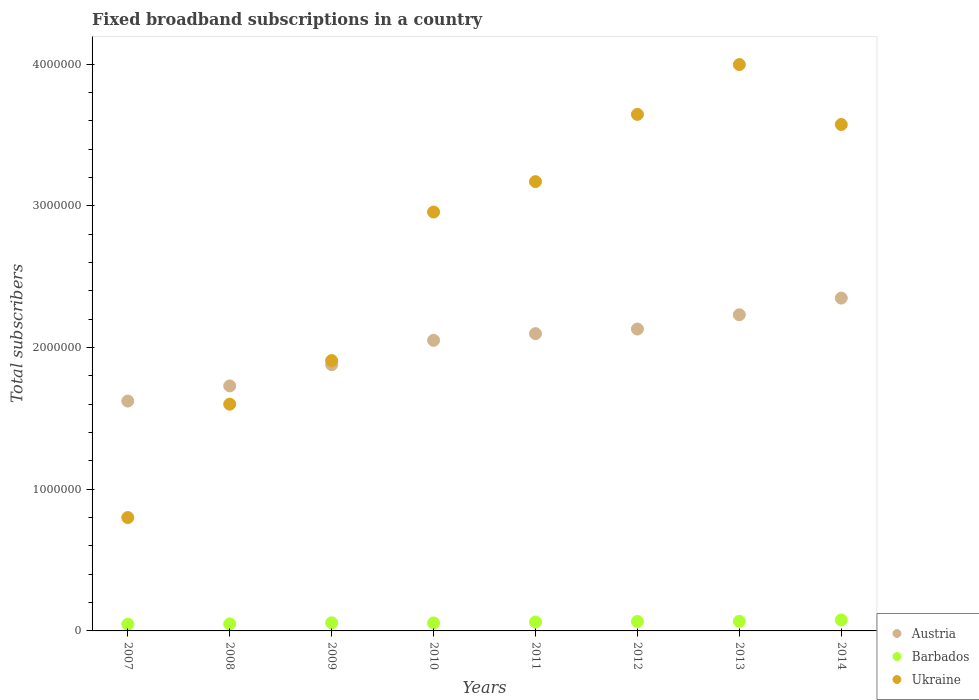How many different coloured dotlines are there?
Ensure brevity in your answer.  3. What is the number of broadband subscriptions in Barbados in 2007?
Provide a short and direct response. 4.71e+04. Across all years, what is the maximum number of broadband subscriptions in Austria?
Offer a very short reply. 2.35e+06. Across all years, what is the minimum number of broadband subscriptions in Barbados?
Offer a very short reply. 4.71e+04. In which year was the number of broadband subscriptions in Austria minimum?
Ensure brevity in your answer.  2007. What is the total number of broadband subscriptions in Barbados in the graph?
Offer a terse response. 4.84e+05. What is the difference between the number of broadband subscriptions in Ukraine in 2007 and that in 2008?
Your response must be concise. -8.00e+05. What is the difference between the number of broadband subscriptions in Barbados in 2013 and the number of broadband subscriptions in Austria in 2007?
Offer a very short reply. -1.55e+06. What is the average number of broadband subscriptions in Austria per year?
Give a very brief answer. 2.01e+06. In the year 2008, what is the difference between the number of broadband subscriptions in Ukraine and number of broadband subscriptions in Austria?
Your response must be concise. -1.29e+05. What is the ratio of the number of broadband subscriptions in Austria in 2007 to that in 2014?
Ensure brevity in your answer.  0.69. Is the number of broadband subscriptions in Ukraine in 2007 less than that in 2012?
Ensure brevity in your answer.  Yes. Is the difference between the number of broadband subscriptions in Ukraine in 2011 and 2012 greater than the difference between the number of broadband subscriptions in Austria in 2011 and 2012?
Ensure brevity in your answer.  No. What is the difference between the highest and the second highest number of broadband subscriptions in Barbados?
Ensure brevity in your answer.  9360. What is the difference between the highest and the lowest number of broadband subscriptions in Austria?
Keep it short and to the point. 7.27e+05. In how many years, is the number of broadband subscriptions in Barbados greater than the average number of broadband subscriptions in Barbados taken over all years?
Provide a succinct answer. 4. How many dotlines are there?
Your response must be concise. 3. Are the values on the major ticks of Y-axis written in scientific E-notation?
Your answer should be very brief. No. Does the graph contain grids?
Offer a very short reply. No. How many legend labels are there?
Provide a succinct answer. 3. What is the title of the graph?
Make the answer very short. Fixed broadband subscriptions in a country. What is the label or title of the X-axis?
Offer a very short reply. Years. What is the label or title of the Y-axis?
Provide a short and direct response. Total subscribers. What is the Total subscribers in Austria in 2007?
Make the answer very short. 1.62e+06. What is the Total subscribers in Barbados in 2007?
Ensure brevity in your answer.  4.71e+04. What is the Total subscribers in Ukraine in 2007?
Keep it short and to the point. 8.00e+05. What is the Total subscribers of Austria in 2008?
Make the answer very short. 1.73e+06. What is the Total subscribers in Barbados in 2008?
Your answer should be compact. 4.92e+04. What is the Total subscribers of Ukraine in 2008?
Offer a terse response. 1.60e+06. What is the Total subscribers in Austria in 2009?
Give a very brief answer. 1.88e+06. What is the Total subscribers in Barbados in 2009?
Your answer should be compact. 5.73e+04. What is the Total subscribers of Ukraine in 2009?
Give a very brief answer. 1.91e+06. What is the Total subscribers of Austria in 2010?
Ensure brevity in your answer.  2.05e+06. What is the Total subscribers of Barbados in 2010?
Make the answer very short. 5.62e+04. What is the Total subscribers in Ukraine in 2010?
Keep it short and to the point. 2.96e+06. What is the Total subscribers in Austria in 2011?
Offer a terse response. 2.10e+06. What is the Total subscribers in Barbados in 2011?
Give a very brief answer. 6.26e+04. What is the Total subscribers in Ukraine in 2011?
Your answer should be compact. 3.17e+06. What is the Total subscribers in Austria in 2012?
Make the answer very short. 2.13e+06. What is the Total subscribers of Barbados in 2012?
Offer a terse response. 6.69e+04. What is the Total subscribers in Ukraine in 2012?
Provide a short and direct response. 3.64e+06. What is the Total subscribers in Austria in 2013?
Offer a terse response. 2.23e+06. What is the Total subscribers in Barbados in 2013?
Your answer should be compact. 6.78e+04. What is the Total subscribers in Ukraine in 2013?
Your answer should be very brief. 4.00e+06. What is the Total subscribers in Austria in 2014?
Ensure brevity in your answer.  2.35e+06. What is the Total subscribers of Barbados in 2014?
Offer a terse response. 7.72e+04. What is the Total subscribers of Ukraine in 2014?
Make the answer very short. 3.57e+06. Across all years, what is the maximum Total subscribers in Austria?
Your answer should be very brief. 2.35e+06. Across all years, what is the maximum Total subscribers of Barbados?
Offer a terse response. 7.72e+04. Across all years, what is the maximum Total subscribers in Ukraine?
Your answer should be very brief. 4.00e+06. Across all years, what is the minimum Total subscribers of Austria?
Offer a very short reply. 1.62e+06. Across all years, what is the minimum Total subscribers of Barbados?
Offer a very short reply. 4.71e+04. Across all years, what is the minimum Total subscribers in Ukraine?
Provide a succinct answer. 8.00e+05. What is the total Total subscribers in Austria in the graph?
Ensure brevity in your answer.  1.61e+07. What is the total Total subscribers of Barbados in the graph?
Offer a very short reply. 4.84e+05. What is the total Total subscribers of Ukraine in the graph?
Your response must be concise. 2.16e+07. What is the difference between the Total subscribers in Austria in 2007 and that in 2008?
Your answer should be very brief. -1.07e+05. What is the difference between the Total subscribers of Barbados in 2007 and that in 2008?
Provide a succinct answer. -2083. What is the difference between the Total subscribers in Ukraine in 2007 and that in 2008?
Your response must be concise. -8.00e+05. What is the difference between the Total subscribers of Austria in 2007 and that in 2009?
Provide a short and direct response. -2.57e+05. What is the difference between the Total subscribers of Barbados in 2007 and that in 2009?
Your response must be concise. -1.02e+04. What is the difference between the Total subscribers of Ukraine in 2007 and that in 2009?
Offer a terse response. -1.11e+06. What is the difference between the Total subscribers of Austria in 2007 and that in 2010?
Your response must be concise. -4.28e+05. What is the difference between the Total subscribers of Barbados in 2007 and that in 2010?
Your answer should be very brief. -9057. What is the difference between the Total subscribers in Ukraine in 2007 and that in 2010?
Make the answer very short. -2.16e+06. What is the difference between the Total subscribers of Austria in 2007 and that in 2011?
Your answer should be very brief. -4.76e+05. What is the difference between the Total subscribers of Barbados in 2007 and that in 2011?
Provide a succinct answer. -1.55e+04. What is the difference between the Total subscribers of Ukraine in 2007 and that in 2011?
Provide a short and direct response. -2.37e+06. What is the difference between the Total subscribers in Austria in 2007 and that in 2012?
Ensure brevity in your answer.  -5.08e+05. What is the difference between the Total subscribers in Barbados in 2007 and that in 2012?
Your response must be concise. -1.98e+04. What is the difference between the Total subscribers in Ukraine in 2007 and that in 2012?
Offer a terse response. -2.84e+06. What is the difference between the Total subscribers in Austria in 2007 and that in 2013?
Offer a terse response. -6.09e+05. What is the difference between the Total subscribers in Barbados in 2007 and that in 2013?
Ensure brevity in your answer.  -2.07e+04. What is the difference between the Total subscribers in Ukraine in 2007 and that in 2013?
Your answer should be very brief. -3.20e+06. What is the difference between the Total subscribers of Austria in 2007 and that in 2014?
Your answer should be very brief. -7.27e+05. What is the difference between the Total subscribers in Barbados in 2007 and that in 2014?
Your response must be concise. -3.00e+04. What is the difference between the Total subscribers of Ukraine in 2007 and that in 2014?
Make the answer very short. -2.77e+06. What is the difference between the Total subscribers in Austria in 2008 and that in 2009?
Your answer should be compact. -1.50e+05. What is the difference between the Total subscribers in Barbados in 2008 and that in 2009?
Keep it short and to the point. -8089. What is the difference between the Total subscribers of Ukraine in 2008 and that in 2009?
Give a very brief answer. -3.08e+05. What is the difference between the Total subscribers of Austria in 2008 and that in 2010?
Make the answer very short. -3.21e+05. What is the difference between the Total subscribers of Barbados in 2008 and that in 2010?
Give a very brief answer. -6974. What is the difference between the Total subscribers in Ukraine in 2008 and that in 2010?
Give a very brief answer. -1.36e+06. What is the difference between the Total subscribers in Austria in 2008 and that in 2011?
Your answer should be compact. -3.69e+05. What is the difference between the Total subscribers in Barbados in 2008 and that in 2011?
Offer a terse response. -1.34e+04. What is the difference between the Total subscribers in Ukraine in 2008 and that in 2011?
Offer a terse response. -1.57e+06. What is the difference between the Total subscribers in Austria in 2008 and that in 2012?
Your answer should be very brief. -4.01e+05. What is the difference between the Total subscribers of Barbados in 2008 and that in 2012?
Provide a succinct answer. -1.77e+04. What is the difference between the Total subscribers of Ukraine in 2008 and that in 2012?
Make the answer very short. -2.04e+06. What is the difference between the Total subscribers of Austria in 2008 and that in 2013?
Ensure brevity in your answer.  -5.02e+05. What is the difference between the Total subscribers of Barbados in 2008 and that in 2013?
Your answer should be compact. -1.86e+04. What is the difference between the Total subscribers of Ukraine in 2008 and that in 2013?
Give a very brief answer. -2.40e+06. What is the difference between the Total subscribers in Austria in 2008 and that in 2014?
Keep it short and to the point. -6.20e+05. What is the difference between the Total subscribers of Barbados in 2008 and that in 2014?
Your response must be concise. -2.79e+04. What is the difference between the Total subscribers of Ukraine in 2008 and that in 2014?
Your answer should be very brief. -1.97e+06. What is the difference between the Total subscribers in Austria in 2009 and that in 2010?
Give a very brief answer. -1.72e+05. What is the difference between the Total subscribers in Barbados in 2009 and that in 2010?
Offer a terse response. 1115. What is the difference between the Total subscribers of Ukraine in 2009 and that in 2010?
Offer a very short reply. -1.05e+06. What is the difference between the Total subscribers of Austria in 2009 and that in 2011?
Make the answer very short. -2.19e+05. What is the difference between the Total subscribers in Barbados in 2009 and that in 2011?
Ensure brevity in your answer.  -5329. What is the difference between the Total subscribers in Ukraine in 2009 and that in 2011?
Your answer should be very brief. -1.26e+06. What is the difference between the Total subscribers in Austria in 2009 and that in 2012?
Provide a succinct answer. -2.52e+05. What is the difference between the Total subscribers of Barbados in 2009 and that in 2012?
Keep it short and to the point. -9579. What is the difference between the Total subscribers in Ukraine in 2009 and that in 2012?
Give a very brief answer. -1.74e+06. What is the difference between the Total subscribers of Austria in 2009 and that in 2013?
Offer a terse response. -3.52e+05. What is the difference between the Total subscribers in Barbados in 2009 and that in 2013?
Your response must be concise. -1.05e+04. What is the difference between the Total subscribers of Ukraine in 2009 and that in 2013?
Offer a very short reply. -2.09e+06. What is the difference between the Total subscribers in Austria in 2009 and that in 2014?
Provide a short and direct response. -4.70e+05. What is the difference between the Total subscribers of Barbados in 2009 and that in 2014?
Your answer should be very brief. -1.99e+04. What is the difference between the Total subscribers of Ukraine in 2009 and that in 2014?
Your answer should be compact. -1.67e+06. What is the difference between the Total subscribers in Austria in 2010 and that in 2011?
Your answer should be very brief. -4.73e+04. What is the difference between the Total subscribers in Barbados in 2010 and that in 2011?
Offer a terse response. -6444. What is the difference between the Total subscribers in Ukraine in 2010 and that in 2011?
Your answer should be compact. -2.15e+05. What is the difference between the Total subscribers of Austria in 2010 and that in 2012?
Offer a terse response. -7.98e+04. What is the difference between the Total subscribers of Barbados in 2010 and that in 2012?
Provide a succinct answer. -1.07e+04. What is the difference between the Total subscribers in Ukraine in 2010 and that in 2012?
Ensure brevity in your answer.  -6.89e+05. What is the difference between the Total subscribers in Austria in 2010 and that in 2013?
Offer a very short reply. -1.81e+05. What is the difference between the Total subscribers of Barbados in 2010 and that in 2013?
Provide a succinct answer. -1.16e+04. What is the difference between the Total subscribers in Ukraine in 2010 and that in 2013?
Keep it short and to the point. -1.04e+06. What is the difference between the Total subscribers in Austria in 2010 and that in 2014?
Your answer should be compact. -2.98e+05. What is the difference between the Total subscribers in Barbados in 2010 and that in 2014?
Ensure brevity in your answer.  -2.10e+04. What is the difference between the Total subscribers of Ukraine in 2010 and that in 2014?
Give a very brief answer. -6.18e+05. What is the difference between the Total subscribers in Austria in 2011 and that in 2012?
Provide a short and direct response. -3.25e+04. What is the difference between the Total subscribers of Barbados in 2011 and that in 2012?
Ensure brevity in your answer.  -4250. What is the difference between the Total subscribers of Ukraine in 2011 and that in 2012?
Your answer should be very brief. -4.75e+05. What is the difference between the Total subscribers of Austria in 2011 and that in 2013?
Your answer should be very brief. -1.33e+05. What is the difference between the Total subscribers of Barbados in 2011 and that in 2013?
Give a very brief answer. -5164. What is the difference between the Total subscribers of Ukraine in 2011 and that in 2013?
Offer a terse response. -8.26e+05. What is the difference between the Total subscribers of Austria in 2011 and that in 2014?
Keep it short and to the point. -2.51e+05. What is the difference between the Total subscribers in Barbados in 2011 and that in 2014?
Make the answer very short. -1.45e+04. What is the difference between the Total subscribers of Ukraine in 2011 and that in 2014?
Ensure brevity in your answer.  -4.03e+05. What is the difference between the Total subscribers of Austria in 2012 and that in 2013?
Offer a terse response. -1.01e+05. What is the difference between the Total subscribers in Barbados in 2012 and that in 2013?
Ensure brevity in your answer.  -914. What is the difference between the Total subscribers in Ukraine in 2012 and that in 2013?
Ensure brevity in your answer.  -3.52e+05. What is the difference between the Total subscribers of Austria in 2012 and that in 2014?
Your response must be concise. -2.18e+05. What is the difference between the Total subscribers of Barbados in 2012 and that in 2014?
Your answer should be very brief. -1.03e+04. What is the difference between the Total subscribers in Ukraine in 2012 and that in 2014?
Ensure brevity in your answer.  7.15e+04. What is the difference between the Total subscribers of Austria in 2013 and that in 2014?
Make the answer very short. -1.18e+05. What is the difference between the Total subscribers of Barbados in 2013 and that in 2014?
Provide a short and direct response. -9360. What is the difference between the Total subscribers of Ukraine in 2013 and that in 2014?
Your answer should be very brief. 4.23e+05. What is the difference between the Total subscribers of Austria in 2007 and the Total subscribers of Barbados in 2008?
Make the answer very short. 1.57e+06. What is the difference between the Total subscribers of Austria in 2007 and the Total subscribers of Ukraine in 2008?
Provide a short and direct response. 2.20e+04. What is the difference between the Total subscribers of Barbados in 2007 and the Total subscribers of Ukraine in 2008?
Ensure brevity in your answer.  -1.55e+06. What is the difference between the Total subscribers of Austria in 2007 and the Total subscribers of Barbados in 2009?
Your answer should be very brief. 1.56e+06. What is the difference between the Total subscribers of Austria in 2007 and the Total subscribers of Ukraine in 2009?
Make the answer very short. -2.86e+05. What is the difference between the Total subscribers of Barbados in 2007 and the Total subscribers of Ukraine in 2009?
Keep it short and to the point. -1.86e+06. What is the difference between the Total subscribers of Austria in 2007 and the Total subscribers of Barbados in 2010?
Your answer should be compact. 1.57e+06. What is the difference between the Total subscribers in Austria in 2007 and the Total subscribers in Ukraine in 2010?
Provide a short and direct response. -1.33e+06. What is the difference between the Total subscribers in Barbados in 2007 and the Total subscribers in Ukraine in 2010?
Your response must be concise. -2.91e+06. What is the difference between the Total subscribers of Austria in 2007 and the Total subscribers of Barbados in 2011?
Your response must be concise. 1.56e+06. What is the difference between the Total subscribers in Austria in 2007 and the Total subscribers in Ukraine in 2011?
Offer a terse response. -1.55e+06. What is the difference between the Total subscribers of Barbados in 2007 and the Total subscribers of Ukraine in 2011?
Your answer should be compact. -3.12e+06. What is the difference between the Total subscribers of Austria in 2007 and the Total subscribers of Barbados in 2012?
Give a very brief answer. 1.56e+06. What is the difference between the Total subscribers of Austria in 2007 and the Total subscribers of Ukraine in 2012?
Your answer should be compact. -2.02e+06. What is the difference between the Total subscribers of Barbados in 2007 and the Total subscribers of Ukraine in 2012?
Make the answer very short. -3.60e+06. What is the difference between the Total subscribers in Austria in 2007 and the Total subscribers in Barbados in 2013?
Give a very brief answer. 1.55e+06. What is the difference between the Total subscribers of Austria in 2007 and the Total subscribers of Ukraine in 2013?
Your response must be concise. -2.37e+06. What is the difference between the Total subscribers in Barbados in 2007 and the Total subscribers in Ukraine in 2013?
Offer a terse response. -3.95e+06. What is the difference between the Total subscribers in Austria in 2007 and the Total subscribers in Barbados in 2014?
Give a very brief answer. 1.54e+06. What is the difference between the Total subscribers in Austria in 2007 and the Total subscribers in Ukraine in 2014?
Your answer should be compact. -1.95e+06. What is the difference between the Total subscribers in Barbados in 2007 and the Total subscribers in Ukraine in 2014?
Your response must be concise. -3.53e+06. What is the difference between the Total subscribers of Austria in 2008 and the Total subscribers of Barbados in 2009?
Provide a short and direct response. 1.67e+06. What is the difference between the Total subscribers in Austria in 2008 and the Total subscribers in Ukraine in 2009?
Your answer should be compact. -1.79e+05. What is the difference between the Total subscribers of Barbados in 2008 and the Total subscribers of Ukraine in 2009?
Make the answer very short. -1.86e+06. What is the difference between the Total subscribers in Austria in 2008 and the Total subscribers in Barbados in 2010?
Provide a short and direct response. 1.67e+06. What is the difference between the Total subscribers in Austria in 2008 and the Total subscribers in Ukraine in 2010?
Give a very brief answer. -1.23e+06. What is the difference between the Total subscribers in Barbados in 2008 and the Total subscribers in Ukraine in 2010?
Provide a short and direct response. -2.91e+06. What is the difference between the Total subscribers in Austria in 2008 and the Total subscribers in Barbados in 2011?
Your answer should be compact. 1.67e+06. What is the difference between the Total subscribers in Austria in 2008 and the Total subscribers in Ukraine in 2011?
Make the answer very short. -1.44e+06. What is the difference between the Total subscribers in Barbados in 2008 and the Total subscribers in Ukraine in 2011?
Keep it short and to the point. -3.12e+06. What is the difference between the Total subscribers of Austria in 2008 and the Total subscribers of Barbados in 2012?
Make the answer very short. 1.66e+06. What is the difference between the Total subscribers in Austria in 2008 and the Total subscribers in Ukraine in 2012?
Offer a very short reply. -1.92e+06. What is the difference between the Total subscribers of Barbados in 2008 and the Total subscribers of Ukraine in 2012?
Your response must be concise. -3.60e+06. What is the difference between the Total subscribers of Austria in 2008 and the Total subscribers of Barbados in 2013?
Offer a terse response. 1.66e+06. What is the difference between the Total subscribers in Austria in 2008 and the Total subscribers in Ukraine in 2013?
Give a very brief answer. -2.27e+06. What is the difference between the Total subscribers in Barbados in 2008 and the Total subscribers in Ukraine in 2013?
Your answer should be compact. -3.95e+06. What is the difference between the Total subscribers of Austria in 2008 and the Total subscribers of Barbados in 2014?
Give a very brief answer. 1.65e+06. What is the difference between the Total subscribers in Austria in 2008 and the Total subscribers in Ukraine in 2014?
Offer a terse response. -1.84e+06. What is the difference between the Total subscribers of Barbados in 2008 and the Total subscribers of Ukraine in 2014?
Offer a very short reply. -3.52e+06. What is the difference between the Total subscribers in Austria in 2009 and the Total subscribers in Barbados in 2010?
Make the answer very short. 1.82e+06. What is the difference between the Total subscribers of Austria in 2009 and the Total subscribers of Ukraine in 2010?
Give a very brief answer. -1.08e+06. What is the difference between the Total subscribers in Barbados in 2009 and the Total subscribers in Ukraine in 2010?
Provide a short and direct response. -2.90e+06. What is the difference between the Total subscribers in Austria in 2009 and the Total subscribers in Barbados in 2011?
Your response must be concise. 1.82e+06. What is the difference between the Total subscribers of Austria in 2009 and the Total subscribers of Ukraine in 2011?
Make the answer very short. -1.29e+06. What is the difference between the Total subscribers of Barbados in 2009 and the Total subscribers of Ukraine in 2011?
Your answer should be compact. -3.11e+06. What is the difference between the Total subscribers in Austria in 2009 and the Total subscribers in Barbados in 2012?
Ensure brevity in your answer.  1.81e+06. What is the difference between the Total subscribers of Austria in 2009 and the Total subscribers of Ukraine in 2012?
Your answer should be very brief. -1.77e+06. What is the difference between the Total subscribers of Barbados in 2009 and the Total subscribers of Ukraine in 2012?
Ensure brevity in your answer.  -3.59e+06. What is the difference between the Total subscribers of Austria in 2009 and the Total subscribers of Barbados in 2013?
Provide a short and direct response. 1.81e+06. What is the difference between the Total subscribers in Austria in 2009 and the Total subscribers in Ukraine in 2013?
Your response must be concise. -2.12e+06. What is the difference between the Total subscribers of Barbados in 2009 and the Total subscribers of Ukraine in 2013?
Your answer should be compact. -3.94e+06. What is the difference between the Total subscribers in Austria in 2009 and the Total subscribers in Barbados in 2014?
Your answer should be compact. 1.80e+06. What is the difference between the Total subscribers in Austria in 2009 and the Total subscribers in Ukraine in 2014?
Your response must be concise. -1.69e+06. What is the difference between the Total subscribers of Barbados in 2009 and the Total subscribers of Ukraine in 2014?
Give a very brief answer. -3.52e+06. What is the difference between the Total subscribers in Austria in 2010 and the Total subscribers in Barbados in 2011?
Offer a very short reply. 1.99e+06. What is the difference between the Total subscribers in Austria in 2010 and the Total subscribers in Ukraine in 2011?
Your answer should be very brief. -1.12e+06. What is the difference between the Total subscribers of Barbados in 2010 and the Total subscribers of Ukraine in 2011?
Your answer should be very brief. -3.11e+06. What is the difference between the Total subscribers of Austria in 2010 and the Total subscribers of Barbados in 2012?
Offer a terse response. 1.98e+06. What is the difference between the Total subscribers in Austria in 2010 and the Total subscribers in Ukraine in 2012?
Offer a terse response. -1.59e+06. What is the difference between the Total subscribers of Barbados in 2010 and the Total subscribers of Ukraine in 2012?
Your answer should be very brief. -3.59e+06. What is the difference between the Total subscribers of Austria in 2010 and the Total subscribers of Barbados in 2013?
Offer a very short reply. 1.98e+06. What is the difference between the Total subscribers in Austria in 2010 and the Total subscribers in Ukraine in 2013?
Your answer should be very brief. -1.95e+06. What is the difference between the Total subscribers in Barbados in 2010 and the Total subscribers in Ukraine in 2013?
Offer a very short reply. -3.94e+06. What is the difference between the Total subscribers in Austria in 2010 and the Total subscribers in Barbados in 2014?
Give a very brief answer. 1.97e+06. What is the difference between the Total subscribers in Austria in 2010 and the Total subscribers in Ukraine in 2014?
Offer a terse response. -1.52e+06. What is the difference between the Total subscribers of Barbados in 2010 and the Total subscribers of Ukraine in 2014?
Your response must be concise. -3.52e+06. What is the difference between the Total subscribers of Austria in 2011 and the Total subscribers of Barbados in 2012?
Your answer should be very brief. 2.03e+06. What is the difference between the Total subscribers of Austria in 2011 and the Total subscribers of Ukraine in 2012?
Your response must be concise. -1.55e+06. What is the difference between the Total subscribers of Barbados in 2011 and the Total subscribers of Ukraine in 2012?
Your answer should be compact. -3.58e+06. What is the difference between the Total subscribers in Austria in 2011 and the Total subscribers in Barbados in 2013?
Ensure brevity in your answer.  2.03e+06. What is the difference between the Total subscribers in Austria in 2011 and the Total subscribers in Ukraine in 2013?
Make the answer very short. -1.90e+06. What is the difference between the Total subscribers in Barbados in 2011 and the Total subscribers in Ukraine in 2013?
Give a very brief answer. -3.93e+06. What is the difference between the Total subscribers in Austria in 2011 and the Total subscribers in Barbados in 2014?
Offer a very short reply. 2.02e+06. What is the difference between the Total subscribers of Austria in 2011 and the Total subscribers of Ukraine in 2014?
Offer a very short reply. -1.48e+06. What is the difference between the Total subscribers in Barbados in 2011 and the Total subscribers in Ukraine in 2014?
Ensure brevity in your answer.  -3.51e+06. What is the difference between the Total subscribers of Austria in 2012 and the Total subscribers of Barbados in 2013?
Your answer should be compact. 2.06e+06. What is the difference between the Total subscribers in Austria in 2012 and the Total subscribers in Ukraine in 2013?
Your answer should be compact. -1.87e+06. What is the difference between the Total subscribers of Barbados in 2012 and the Total subscribers of Ukraine in 2013?
Your answer should be very brief. -3.93e+06. What is the difference between the Total subscribers in Austria in 2012 and the Total subscribers in Barbados in 2014?
Provide a short and direct response. 2.05e+06. What is the difference between the Total subscribers in Austria in 2012 and the Total subscribers in Ukraine in 2014?
Provide a short and direct response. -1.44e+06. What is the difference between the Total subscribers of Barbados in 2012 and the Total subscribers of Ukraine in 2014?
Make the answer very short. -3.51e+06. What is the difference between the Total subscribers of Austria in 2013 and the Total subscribers of Barbados in 2014?
Make the answer very short. 2.15e+06. What is the difference between the Total subscribers of Austria in 2013 and the Total subscribers of Ukraine in 2014?
Provide a short and direct response. -1.34e+06. What is the difference between the Total subscribers in Barbados in 2013 and the Total subscribers in Ukraine in 2014?
Offer a terse response. -3.51e+06. What is the average Total subscribers of Austria per year?
Make the answer very short. 2.01e+06. What is the average Total subscribers of Barbados per year?
Offer a terse response. 6.05e+04. What is the average Total subscribers of Ukraine per year?
Make the answer very short. 2.71e+06. In the year 2007, what is the difference between the Total subscribers of Austria and Total subscribers of Barbados?
Provide a short and direct response. 1.57e+06. In the year 2007, what is the difference between the Total subscribers of Austria and Total subscribers of Ukraine?
Your answer should be compact. 8.22e+05. In the year 2007, what is the difference between the Total subscribers of Barbados and Total subscribers of Ukraine?
Provide a succinct answer. -7.53e+05. In the year 2008, what is the difference between the Total subscribers in Austria and Total subscribers in Barbados?
Keep it short and to the point. 1.68e+06. In the year 2008, what is the difference between the Total subscribers of Austria and Total subscribers of Ukraine?
Offer a terse response. 1.29e+05. In the year 2008, what is the difference between the Total subscribers of Barbados and Total subscribers of Ukraine?
Your response must be concise. -1.55e+06. In the year 2009, what is the difference between the Total subscribers in Austria and Total subscribers in Barbados?
Ensure brevity in your answer.  1.82e+06. In the year 2009, what is the difference between the Total subscribers of Austria and Total subscribers of Ukraine?
Keep it short and to the point. -2.92e+04. In the year 2009, what is the difference between the Total subscribers in Barbados and Total subscribers in Ukraine?
Your response must be concise. -1.85e+06. In the year 2010, what is the difference between the Total subscribers of Austria and Total subscribers of Barbados?
Your answer should be compact. 1.99e+06. In the year 2010, what is the difference between the Total subscribers in Austria and Total subscribers in Ukraine?
Keep it short and to the point. -9.05e+05. In the year 2010, what is the difference between the Total subscribers in Barbados and Total subscribers in Ukraine?
Your answer should be compact. -2.90e+06. In the year 2011, what is the difference between the Total subscribers in Austria and Total subscribers in Barbados?
Keep it short and to the point. 2.04e+06. In the year 2011, what is the difference between the Total subscribers in Austria and Total subscribers in Ukraine?
Provide a succinct answer. -1.07e+06. In the year 2011, what is the difference between the Total subscribers of Barbados and Total subscribers of Ukraine?
Offer a terse response. -3.11e+06. In the year 2012, what is the difference between the Total subscribers in Austria and Total subscribers in Barbados?
Offer a very short reply. 2.06e+06. In the year 2012, what is the difference between the Total subscribers in Austria and Total subscribers in Ukraine?
Offer a very short reply. -1.51e+06. In the year 2012, what is the difference between the Total subscribers in Barbados and Total subscribers in Ukraine?
Make the answer very short. -3.58e+06. In the year 2013, what is the difference between the Total subscribers in Austria and Total subscribers in Barbados?
Make the answer very short. 2.16e+06. In the year 2013, what is the difference between the Total subscribers of Austria and Total subscribers of Ukraine?
Ensure brevity in your answer.  -1.77e+06. In the year 2013, what is the difference between the Total subscribers in Barbados and Total subscribers in Ukraine?
Give a very brief answer. -3.93e+06. In the year 2014, what is the difference between the Total subscribers of Austria and Total subscribers of Barbados?
Keep it short and to the point. 2.27e+06. In the year 2014, what is the difference between the Total subscribers of Austria and Total subscribers of Ukraine?
Offer a terse response. -1.22e+06. In the year 2014, what is the difference between the Total subscribers of Barbados and Total subscribers of Ukraine?
Ensure brevity in your answer.  -3.50e+06. What is the ratio of the Total subscribers in Austria in 2007 to that in 2008?
Provide a short and direct response. 0.94. What is the ratio of the Total subscribers of Barbados in 2007 to that in 2008?
Offer a very short reply. 0.96. What is the ratio of the Total subscribers in Austria in 2007 to that in 2009?
Ensure brevity in your answer.  0.86. What is the ratio of the Total subscribers in Barbados in 2007 to that in 2009?
Provide a short and direct response. 0.82. What is the ratio of the Total subscribers of Ukraine in 2007 to that in 2009?
Your response must be concise. 0.42. What is the ratio of the Total subscribers in Austria in 2007 to that in 2010?
Give a very brief answer. 0.79. What is the ratio of the Total subscribers of Barbados in 2007 to that in 2010?
Your answer should be compact. 0.84. What is the ratio of the Total subscribers of Ukraine in 2007 to that in 2010?
Offer a terse response. 0.27. What is the ratio of the Total subscribers of Austria in 2007 to that in 2011?
Your answer should be compact. 0.77. What is the ratio of the Total subscribers of Barbados in 2007 to that in 2011?
Your answer should be compact. 0.75. What is the ratio of the Total subscribers of Ukraine in 2007 to that in 2011?
Provide a succinct answer. 0.25. What is the ratio of the Total subscribers in Austria in 2007 to that in 2012?
Offer a very short reply. 0.76. What is the ratio of the Total subscribers in Barbados in 2007 to that in 2012?
Your answer should be compact. 0.7. What is the ratio of the Total subscribers of Ukraine in 2007 to that in 2012?
Your response must be concise. 0.22. What is the ratio of the Total subscribers in Austria in 2007 to that in 2013?
Your answer should be compact. 0.73. What is the ratio of the Total subscribers of Barbados in 2007 to that in 2013?
Make the answer very short. 0.7. What is the ratio of the Total subscribers of Ukraine in 2007 to that in 2013?
Make the answer very short. 0.2. What is the ratio of the Total subscribers in Austria in 2007 to that in 2014?
Your answer should be very brief. 0.69. What is the ratio of the Total subscribers of Barbados in 2007 to that in 2014?
Provide a short and direct response. 0.61. What is the ratio of the Total subscribers in Ukraine in 2007 to that in 2014?
Provide a succinct answer. 0.22. What is the ratio of the Total subscribers in Austria in 2008 to that in 2009?
Your answer should be very brief. 0.92. What is the ratio of the Total subscribers of Barbados in 2008 to that in 2009?
Offer a very short reply. 0.86. What is the ratio of the Total subscribers of Ukraine in 2008 to that in 2009?
Provide a succinct answer. 0.84. What is the ratio of the Total subscribers of Austria in 2008 to that in 2010?
Make the answer very short. 0.84. What is the ratio of the Total subscribers of Barbados in 2008 to that in 2010?
Give a very brief answer. 0.88. What is the ratio of the Total subscribers in Ukraine in 2008 to that in 2010?
Keep it short and to the point. 0.54. What is the ratio of the Total subscribers in Austria in 2008 to that in 2011?
Ensure brevity in your answer.  0.82. What is the ratio of the Total subscribers in Barbados in 2008 to that in 2011?
Your response must be concise. 0.79. What is the ratio of the Total subscribers in Ukraine in 2008 to that in 2011?
Your answer should be compact. 0.5. What is the ratio of the Total subscribers in Austria in 2008 to that in 2012?
Your answer should be very brief. 0.81. What is the ratio of the Total subscribers in Barbados in 2008 to that in 2012?
Offer a terse response. 0.74. What is the ratio of the Total subscribers of Ukraine in 2008 to that in 2012?
Give a very brief answer. 0.44. What is the ratio of the Total subscribers of Austria in 2008 to that in 2013?
Make the answer very short. 0.78. What is the ratio of the Total subscribers in Barbados in 2008 to that in 2013?
Ensure brevity in your answer.  0.73. What is the ratio of the Total subscribers in Ukraine in 2008 to that in 2013?
Keep it short and to the point. 0.4. What is the ratio of the Total subscribers of Austria in 2008 to that in 2014?
Offer a very short reply. 0.74. What is the ratio of the Total subscribers of Barbados in 2008 to that in 2014?
Ensure brevity in your answer.  0.64. What is the ratio of the Total subscribers in Ukraine in 2008 to that in 2014?
Provide a short and direct response. 0.45. What is the ratio of the Total subscribers of Austria in 2009 to that in 2010?
Your answer should be very brief. 0.92. What is the ratio of the Total subscribers in Barbados in 2009 to that in 2010?
Offer a very short reply. 1.02. What is the ratio of the Total subscribers in Ukraine in 2009 to that in 2010?
Your response must be concise. 0.65. What is the ratio of the Total subscribers in Austria in 2009 to that in 2011?
Provide a short and direct response. 0.9. What is the ratio of the Total subscribers of Barbados in 2009 to that in 2011?
Keep it short and to the point. 0.91. What is the ratio of the Total subscribers in Ukraine in 2009 to that in 2011?
Ensure brevity in your answer.  0.6. What is the ratio of the Total subscribers of Austria in 2009 to that in 2012?
Your response must be concise. 0.88. What is the ratio of the Total subscribers of Barbados in 2009 to that in 2012?
Provide a succinct answer. 0.86. What is the ratio of the Total subscribers in Ukraine in 2009 to that in 2012?
Your answer should be compact. 0.52. What is the ratio of the Total subscribers in Austria in 2009 to that in 2013?
Provide a succinct answer. 0.84. What is the ratio of the Total subscribers of Barbados in 2009 to that in 2013?
Ensure brevity in your answer.  0.85. What is the ratio of the Total subscribers of Ukraine in 2009 to that in 2013?
Ensure brevity in your answer.  0.48. What is the ratio of the Total subscribers of Austria in 2009 to that in 2014?
Provide a succinct answer. 0.8. What is the ratio of the Total subscribers in Barbados in 2009 to that in 2014?
Offer a terse response. 0.74. What is the ratio of the Total subscribers in Ukraine in 2009 to that in 2014?
Your answer should be compact. 0.53. What is the ratio of the Total subscribers of Austria in 2010 to that in 2011?
Your answer should be very brief. 0.98. What is the ratio of the Total subscribers of Barbados in 2010 to that in 2011?
Keep it short and to the point. 0.9. What is the ratio of the Total subscribers of Ukraine in 2010 to that in 2011?
Provide a short and direct response. 0.93. What is the ratio of the Total subscribers of Austria in 2010 to that in 2012?
Make the answer very short. 0.96. What is the ratio of the Total subscribers of Barbados in 2010 to that in 2012?
Keep it short and to the point. 0.84. What is the ratio of the Total subscribers in Ukraine in 2010 to that in 2012?
Your answer should be very brief. 0.81. What is the ratio of the Total subscribers in Austria in 2010 to that in 2013?
Your answer should be compact. 0.92. What is the ratio of the Total subscribers in Barbados in 2010 to that in 2013?
Offer a terse response. 0.83. What is the ratio of the Total subscribers in Ukraine in 2010 to that in 2013?
Keep it short and to the point. 0.74. What is the ratio of the Total subscribers in Austria in 2010 to that in 2014?
Your answer should be compact. 0.87. What is the ratio of the Total subscribers of Barbados in 2010 to that in 2014?
Provide a succinct answer. 0.73. What is the ratio of the Total subscribers of Ukraine in 2010 to that in 2014?
Ensure brevity in your answer.  0.83. What is the ratio of the Total subscribers of Austria in 2011 to that in 2012?
Ensure brevity in your answer.  0.98. What is the ratio of the Total subscribers of Barbados in 2011 to that in 2012?
Your answer should be very brief. 0.94. What is the ratio of the Total subscribers of Ukraine in 2011 to that in 2012?
Provide a short and direct response. 0.87. What is the ratio of the Total subscribers in Austria in 2011 to that in 2013?
Provide a short and direct response. 0.94. What is the ratio of the Total subscribers in Barbados in 2011 to that in 2013?
Provide a short and direct response. 0.92. What is the ratio of the Total subscribers of Ukraine in 2011 to that in 2013?
Your response must be concise. 0.79. What is the ratio of the Total subscribers in Austria in 2011 to that in 2014?
Offer a terse response. 0.89. What is the ratio of the Total subscribers of Barbados in 2011 to that in 2014?
Your response must be concise. 0.81. What is the ratio of the Total subscribers in Ukraine in 2011 to that in 2014?
Give a very brief answer. 0.89. What is the ratio of the Total subscribers in Austria in 2012 to that in 2013?
Your answer should be very brief. 0.95. What is the ratio of the Total subscribers of Barbados in 2012 to that in 2013?
Your response must be concise. 0.99. What is the ratio of the Total subscribers of Ukraine in 2012 to that in 2013?
Offer a terse response. 0.91. What is the ratio of the Total subscribers in Austria in 2012 to that in 2014?
Offer a terse response. 0.91. What is the ratio of the Total subscribers in Barbados in 2012 to that in 2014?
Provide a succinct answer. 0.87. What is the ratio of the Total subscribers in Austria in 2013 to that in 2014?
Make the answer very short. 0.95. What is the ratio of the Total subscribers in Barbados in 2013 to that in 2014?
Your answer should be compact. 0.88. What is the ratio of the Total subscribers in Ukraine in 2013 to that in 2014?
Keep it short and to the point. 1.12. What is the difference between the highest and the second highest Total subscribers of Austria?
Your response must be concise. 1.18e+05. What is the difference between the highest and the second highest Total subscribers in Barbados?
Keep it short and to the point. 9360. What is the difference between the highest and the second highest Total subscribers in Ukraine?
Give a very brief answer. 3.52e+05. What is the difference between the highest and the lowest Total subscribers of Austria?
Your answer should be compact. 7.27e+05. What is the difference between the highest and the lowest Total subscribers in Barbados?
Offer a very short reply. 3.00e+04. What is the difference between the highest and the lowest Total subscribers in Ukraine?
Your answer should be compact. 3.20e+06. 